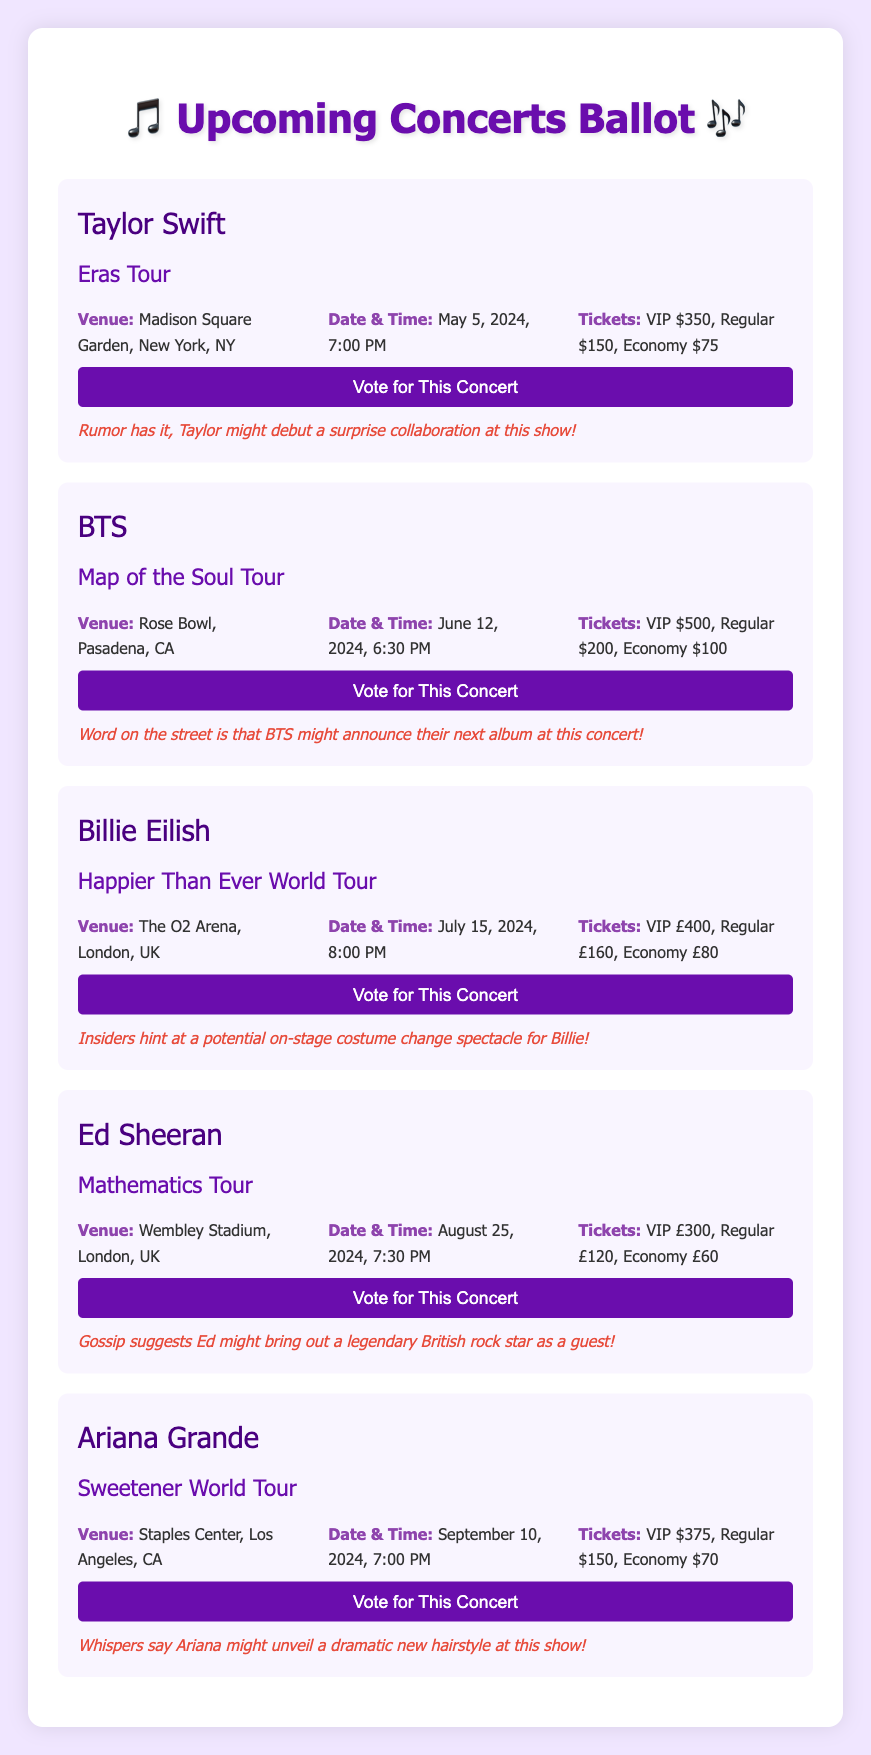What is the name of the concert featuring Taylor Swift? The concert featuring Taylor Swift is called "Eras Tour."
Answer: Eras Tour When is Billie Eilish's concert scheduled? Billie Eilish's concert is scheduled for July 15, 2024, at 8:00 PM.
Answer: July 15, 2024, 8:00 PM What are the ticket prices for Ed Sheeran's Mathematics Tour? The ticket prices for Ed Sheeran's Mathematics Tour are VIP £300, Regular £120, Economy £60.
Answer: VIP £300, Regular £120, Economy £60 Which artist's concert will take place at Madison Square Garden? The concert taking place at Madison Square Garden is by Taylor Swift.
Answer: Taylor Swift What is the date of BTS's Map of the Soul Tour? The date of BTS's Map of the Soul Tour is June 12, 2024.
Answer: June 12, 2024 What is a rumor associated with Ariana Grande's concert? A rumor associated with Ariana Grande's concert is that she might unveil a dramatic new hairstyle.
Answer: A dramatic new hairstyle How many concerts are listed in the document? There are five concerts listed in the document.
Answer: Five What is the venue for Billie Eilish's Happier Than Ever World Tour? The venue for Billie Eilish's tour is The O2 Arena, London, UK.
Answer: The O2 Arena, London, UK Who might make a guest appearance during Ed Sheeran's show? Gossip suggests that a legendary British rock star might be a guest at Ed Sheeran's show.
Answer: A legendary British rock star 